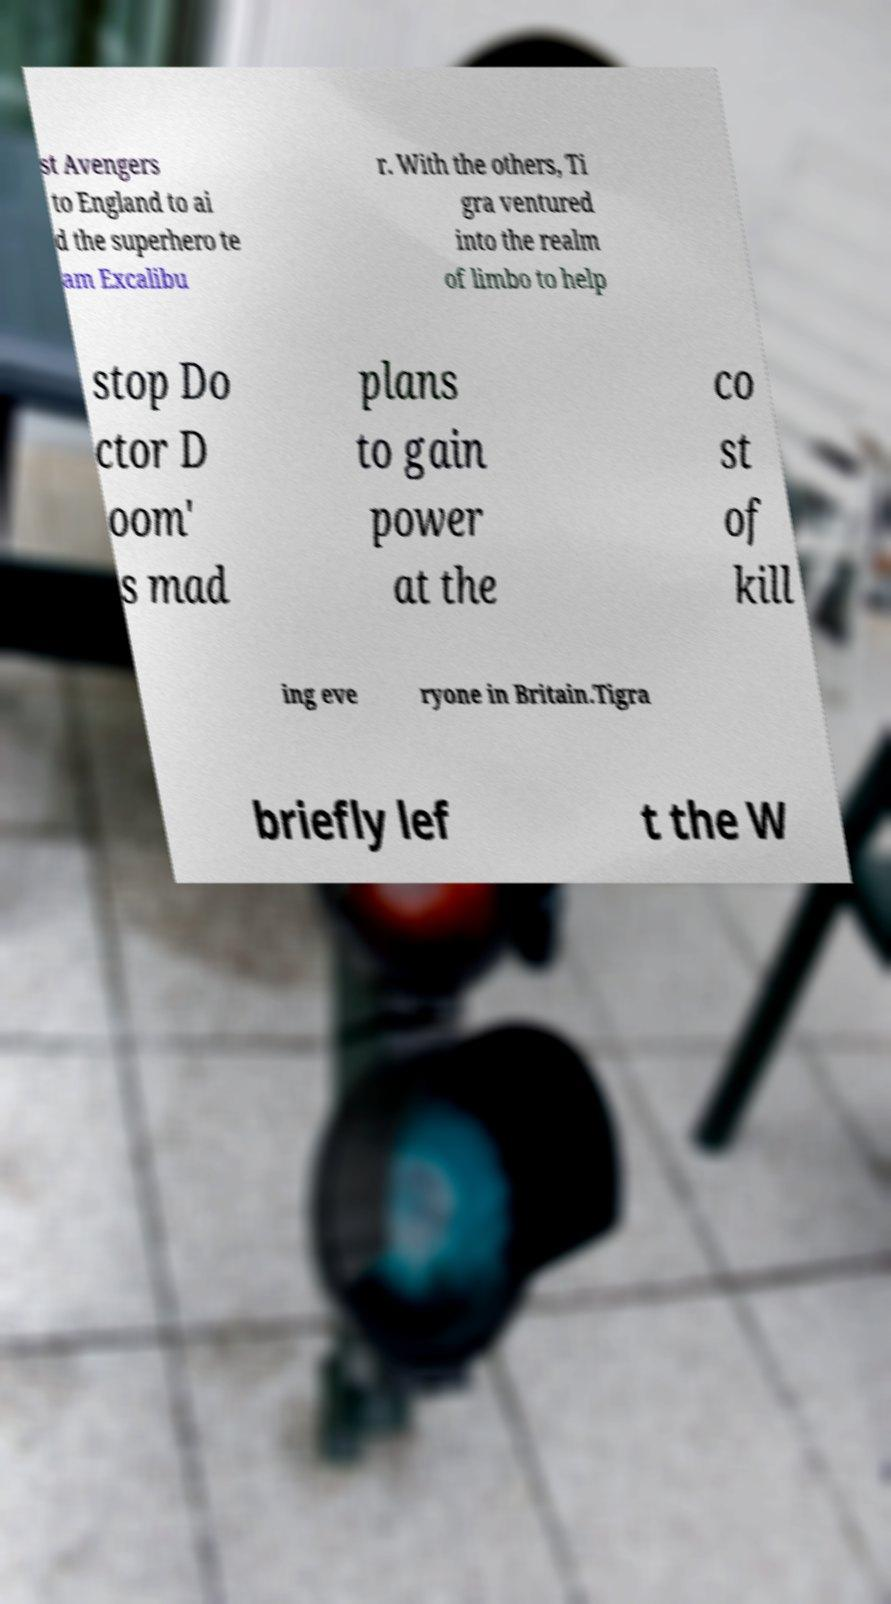There's text embedded in this image that I need extracted. Can you transcribe it verbatim? st Avengers to England to ai d the superhero te am Excalibu r. With the others, Ti gra ventured into the realm of limbo to help stop Do ctor D oom' s mad plans to gain power at the co st of kill ing eve ryone in Britain.Tigra briefly lef t the W 